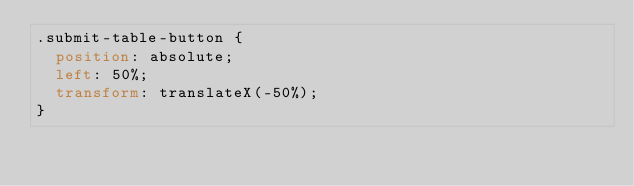<code> <loc_0><loc_0><loc_500><loc_500><_CSS_>.submit-table-button {
  position: absolute;
  left: 50%;
  transform: translateX(-50%);
}
</code> 